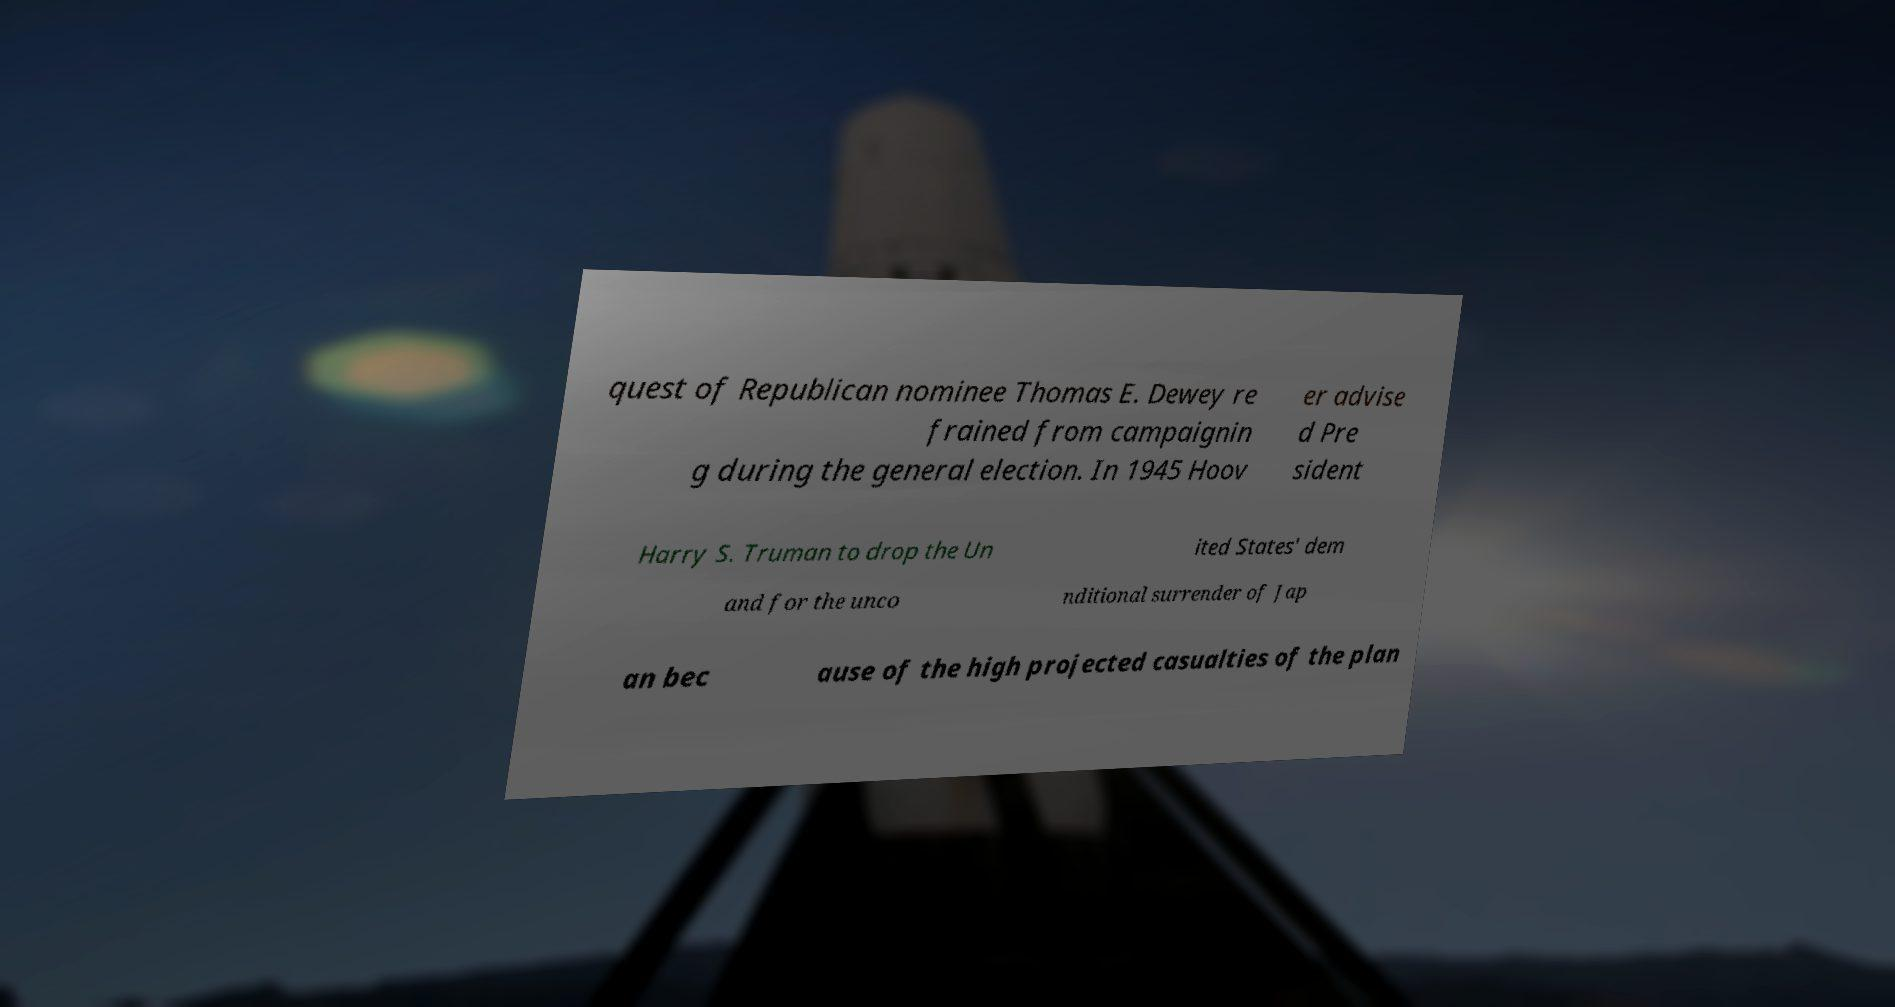Please identify and transcribe the text found in this image. quest of Republican nominee Thomas E. Dewey re frained from campaignin g during the general election. In 1945 Hoov er advise d Pre sident Harry S. Truman to drop the Un ited States' dem and for the unco nditional surrender of Jap an bec ause of the high projected casualties of the plan 